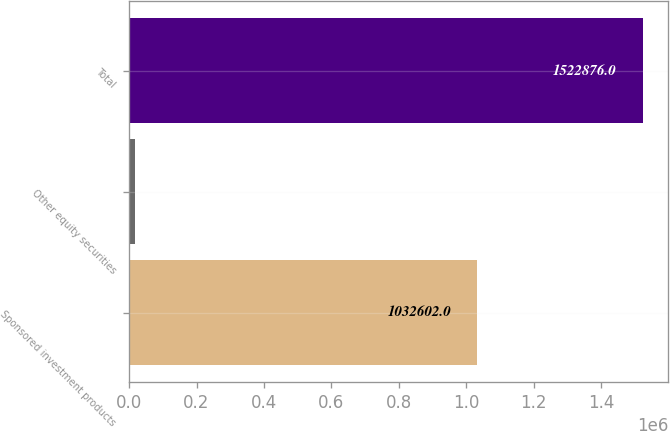Convert chart. <chart><loc_0><loc_0><loc_500><loc_500><bar_chart><fcel>Sponsored investment products<fcel>Other equity securities<fcel>Total<nl><fcel>1.0326e+06<fcel>16931<fcel>1.52288e+06<nl></chart> 